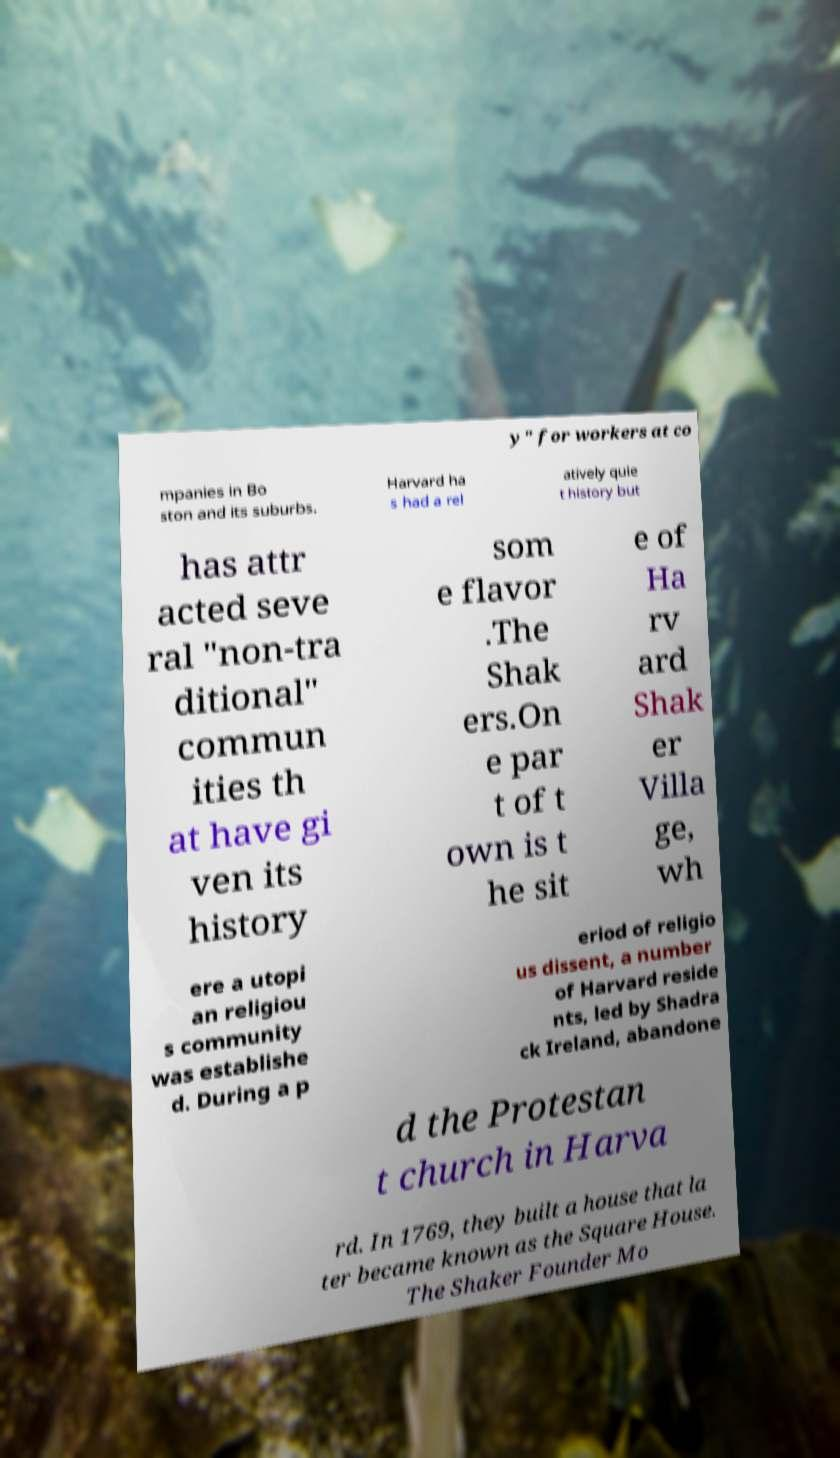Can you accurately transcribe the text from the provided image for me? y" for workers at co mpanies in Bo ston and its suburbs. Harvard ha s had a rel atively quie t history but has attr acted seve ral "non-tra ditional" commun ities th at have gi ven its history som e flavor .The Shak ers.On e par t of t own is t he sit e of Ha rv ard Shak er Villa ge, wh ere a utopi an religiou s community was establishe d. During a p eriod of religio us dissent, a number of Harvard reside nts, led by Shadra ck Ireland, abandone d the Protestan t church in Harva rd. In 1769, they built a house that la ter became known as the Square House. The Shaker Founder Mo 